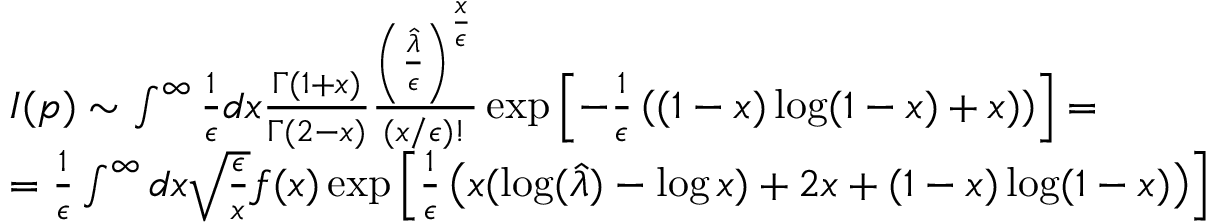<formula> <loc_0><loc_0><loc_500><loc_500>\begin{array} { l } { { I ( p ) \sim \int ^ { \infty } { \frac { 1 } { \epsilon } } d x { \frac { \Gamma ( 1 + x ) } { \Gamma ( 2 - x ) } } { \frac { \left ( { \frac { \hat { \lambda } } { \epsilon } } \right ) ^ { \frac { x } { \epsilon } } } { ( x / \epsilon ) ! } } \exp \left [ - { \frac { 1 } { \epsilon } } \left ( ( 1 - x ) \log ( 1 - x ) + x ) \right ) \right ] = } } \\ { { = { \frac { 1 } { \epsilon } } \int ^ { \infty } d x \sqrt { \frac { \epsilon } { x } } f ( x ) \exp \left [ { \frac { 1 } { \epsilon } } \left ( x ( \log ( { \hat { \lambda } } ) - \log x ) + 2 x + ( 1 - x ) \log ( 1 - x ) \right ) \right ] } } \end{array}</formula> 